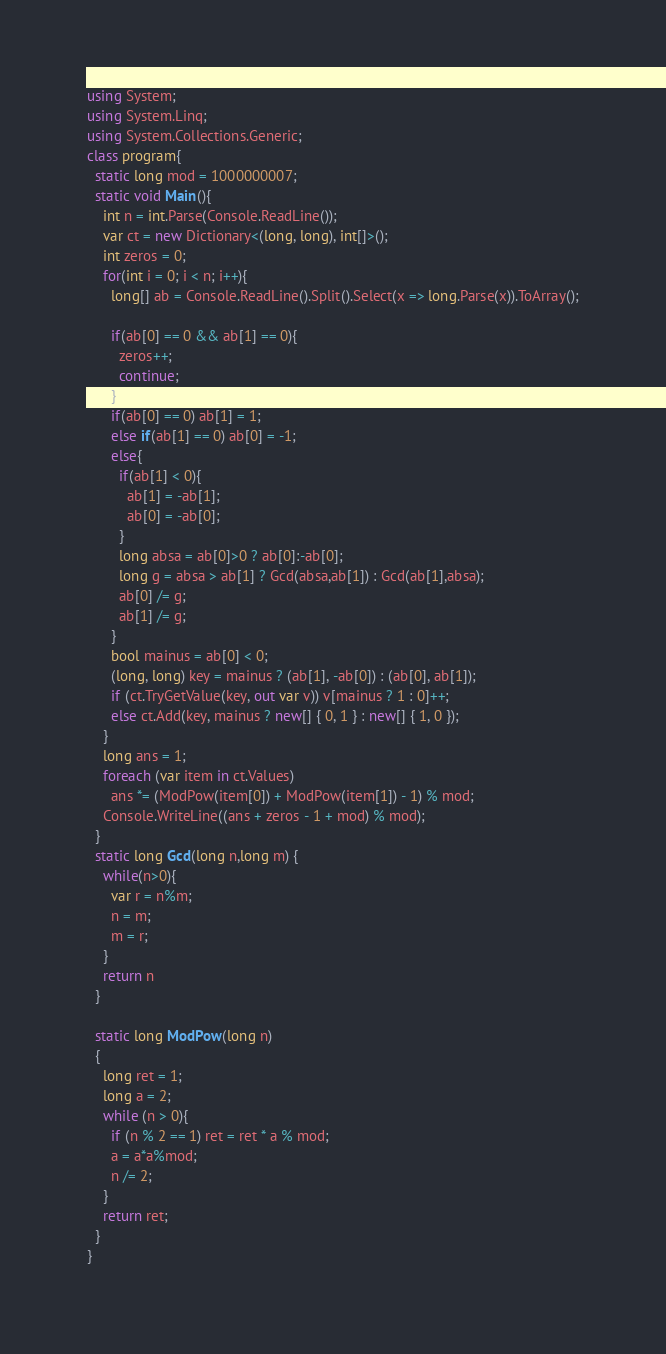<code> <loc_0><loc_0><loc_500><loc_500><_C#_>using System;
using System.Linq;
using System.Collections.Generic;
class program{
  static long mod = 1000000007;
  static void Main(){
    int n = int.Parse(Console.ReadLine());
    var ct = new Dictionary<(long, long), int[]>();
    int zeros = 0;
    for(int i = 0; i < n; i++){
      long[] ab = Console.ReadLine().Split().Select(x => long.Parse(x)).ToArray();
      
      if(ab[0] == 0 && ab[1] == 0){
        zeros++;
        continue;
      }
      if(ab[0] == 0) ab[1] = 1;
      else if(ab[1] == 0) ab[0] = -1;
      else{
        if(ab[1] < 0){
          ab[1] = -ab[1];
          ab[0] = -ab[0];
        }
        long absa = ab[0]>0 ? ab[0]:-ab[0];
        long g = absa > ab[1] ? Gcd(absa,ab[1]) : Gcd(ab[1],absa);
        ab[0] /= g;
        ab[1] /= g;
      }
      bool mainus = ab[0] < 0;
      (long, long) key = mainus ? (ab[1], -ab[0]) : (ab[0], ab[1]);
      if (ct.TryGetValue(key, out var v)) v[mainus ? 1 : 0]++;
      else ct.Add(key, mainus ? new[] { 0, 1 } : new[] { 1, 0 });
    }
    long ans = 1;
    foreach (var item in ct.Values) 
      ans *= (ModPow(item[0]) + ModPow(item[1]) - 1) % mod;
    Console.WriteLine((ans + zeros - 1 + mod) % mod);
  }
  static long Gcd(long n,long m) {
    while(n>0){
      var r = n%m;
      n = m;
      m = r;        
    }
    return n
  }
  
  static long ModPow(long n)
  {
    long ret = 1;
    long a = 2;
    while (n > 0){
      if (n % 2 == 1) ret = ret * a % mod;
      a = a*a%mod;
      n /= 2;
    }
    return ret;
  }
}</code> 